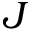Convert formula to latex. <formula><loc_0><loc_0><loc_500><loc_500>J</formula> 